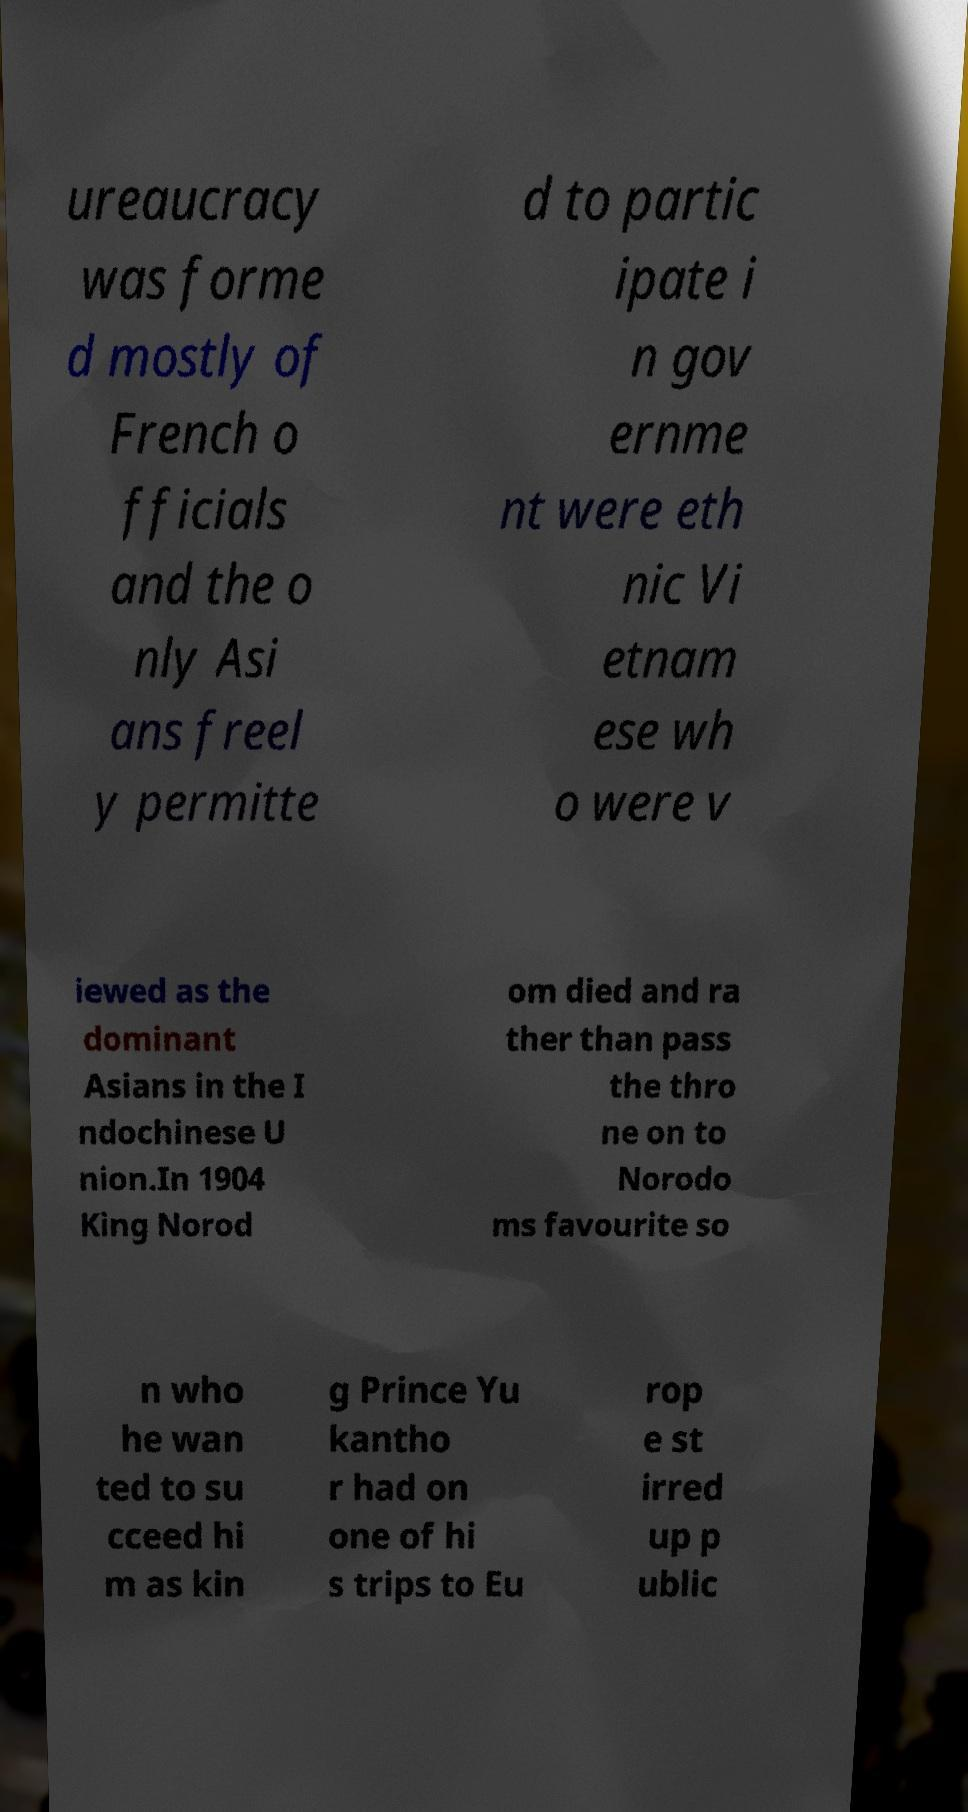Please identify and transcribe the text found in this image. ureaucracy was forme d mostly of French o fficials and the o nly Asi ans freel y permitte d to partic ipate i n gov ernme nt were eth nic Vi etnam ese wh o were v iewed as the dominant Asians in the I ndochinese U nion.In 1904 King Norod om died and ra ther than pass the thro ne on to Norodo ms favourite so n who he wan ted to su cceed hi m as kin g Prince Yu kantho r had on one of hi s trips to Eu rop e st irred up p ublic 